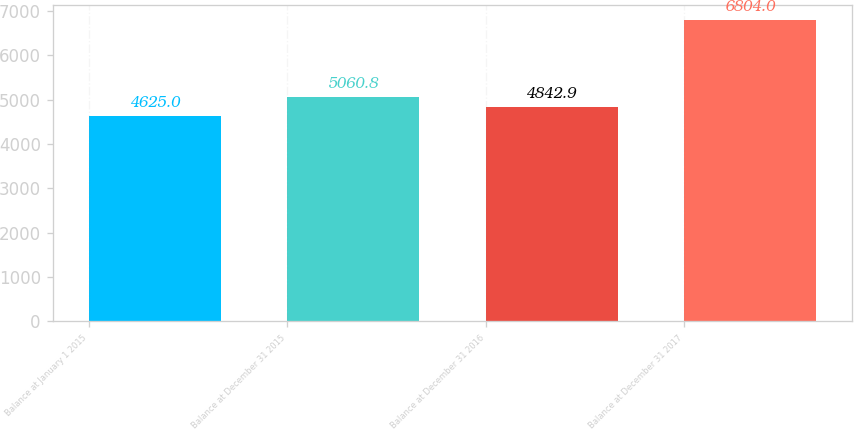<chart> <loc_0><loc_0><loc_500><loc_500><bar_chart><fcel>Balance at January 1 2015<fcel>Balance at December 31 2015<fcel>Balance at December 31 2016<fcel>Balance at December 31 2017<nl><fcel>4625<fcel>5060.8<fcel>4842.9<fcel>6804<nl></chart> 